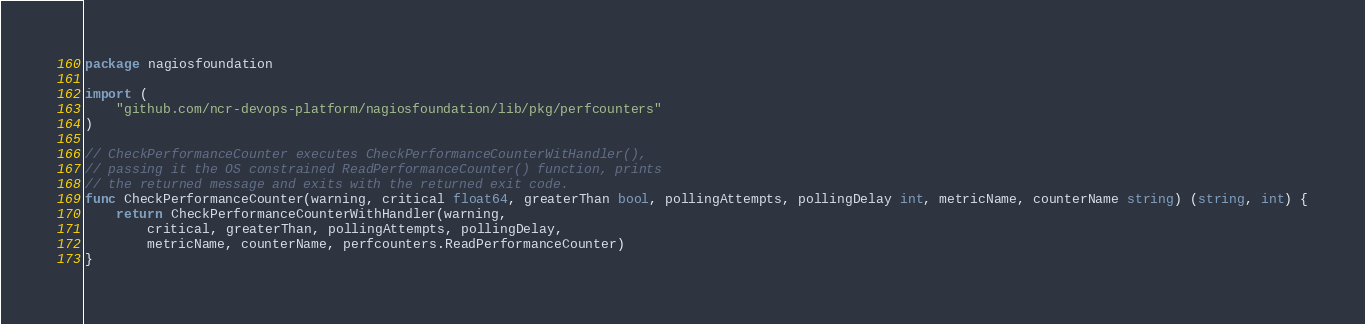Convert code to text. <code><loc_0><loc_0><loc_500><loc_500><_Go_>package nagiosfoundation

import (
	"github.com/ncr-devops-platform/nagiosfoundation/lib/pkg/perfcounters"
)

// CheckPerformanceCounter executes CheckPerformanceCounterWitHandler(),
// passing it the OS constrained ReadPerformanceCounter() function, prints
// the returned message and exits with the returned exit code.
func CheckPerformanceCounter(warning, critical float64, greaterThan bool, pollingAttempts, pollingDelay int, metricName, counterName string) (string, int) {
	return CheckPerformanceCounterWithHandler(warning,
		critical, greaterThan, pollingAttempts, pollingDelay,
		metricName, counterName, perfcounters.ReadPerformanceCounter)
}
</code> 